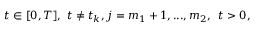Convert formula to latex. <formula><loc_0><loc_0><loc_500><loc_500>t \in [ 0 , T ] , \ t \neq t _ { k } , j = m _ { 1 } + 1 , \dots , m _ { 2 } , \, \ t > 0 ,</formula> 